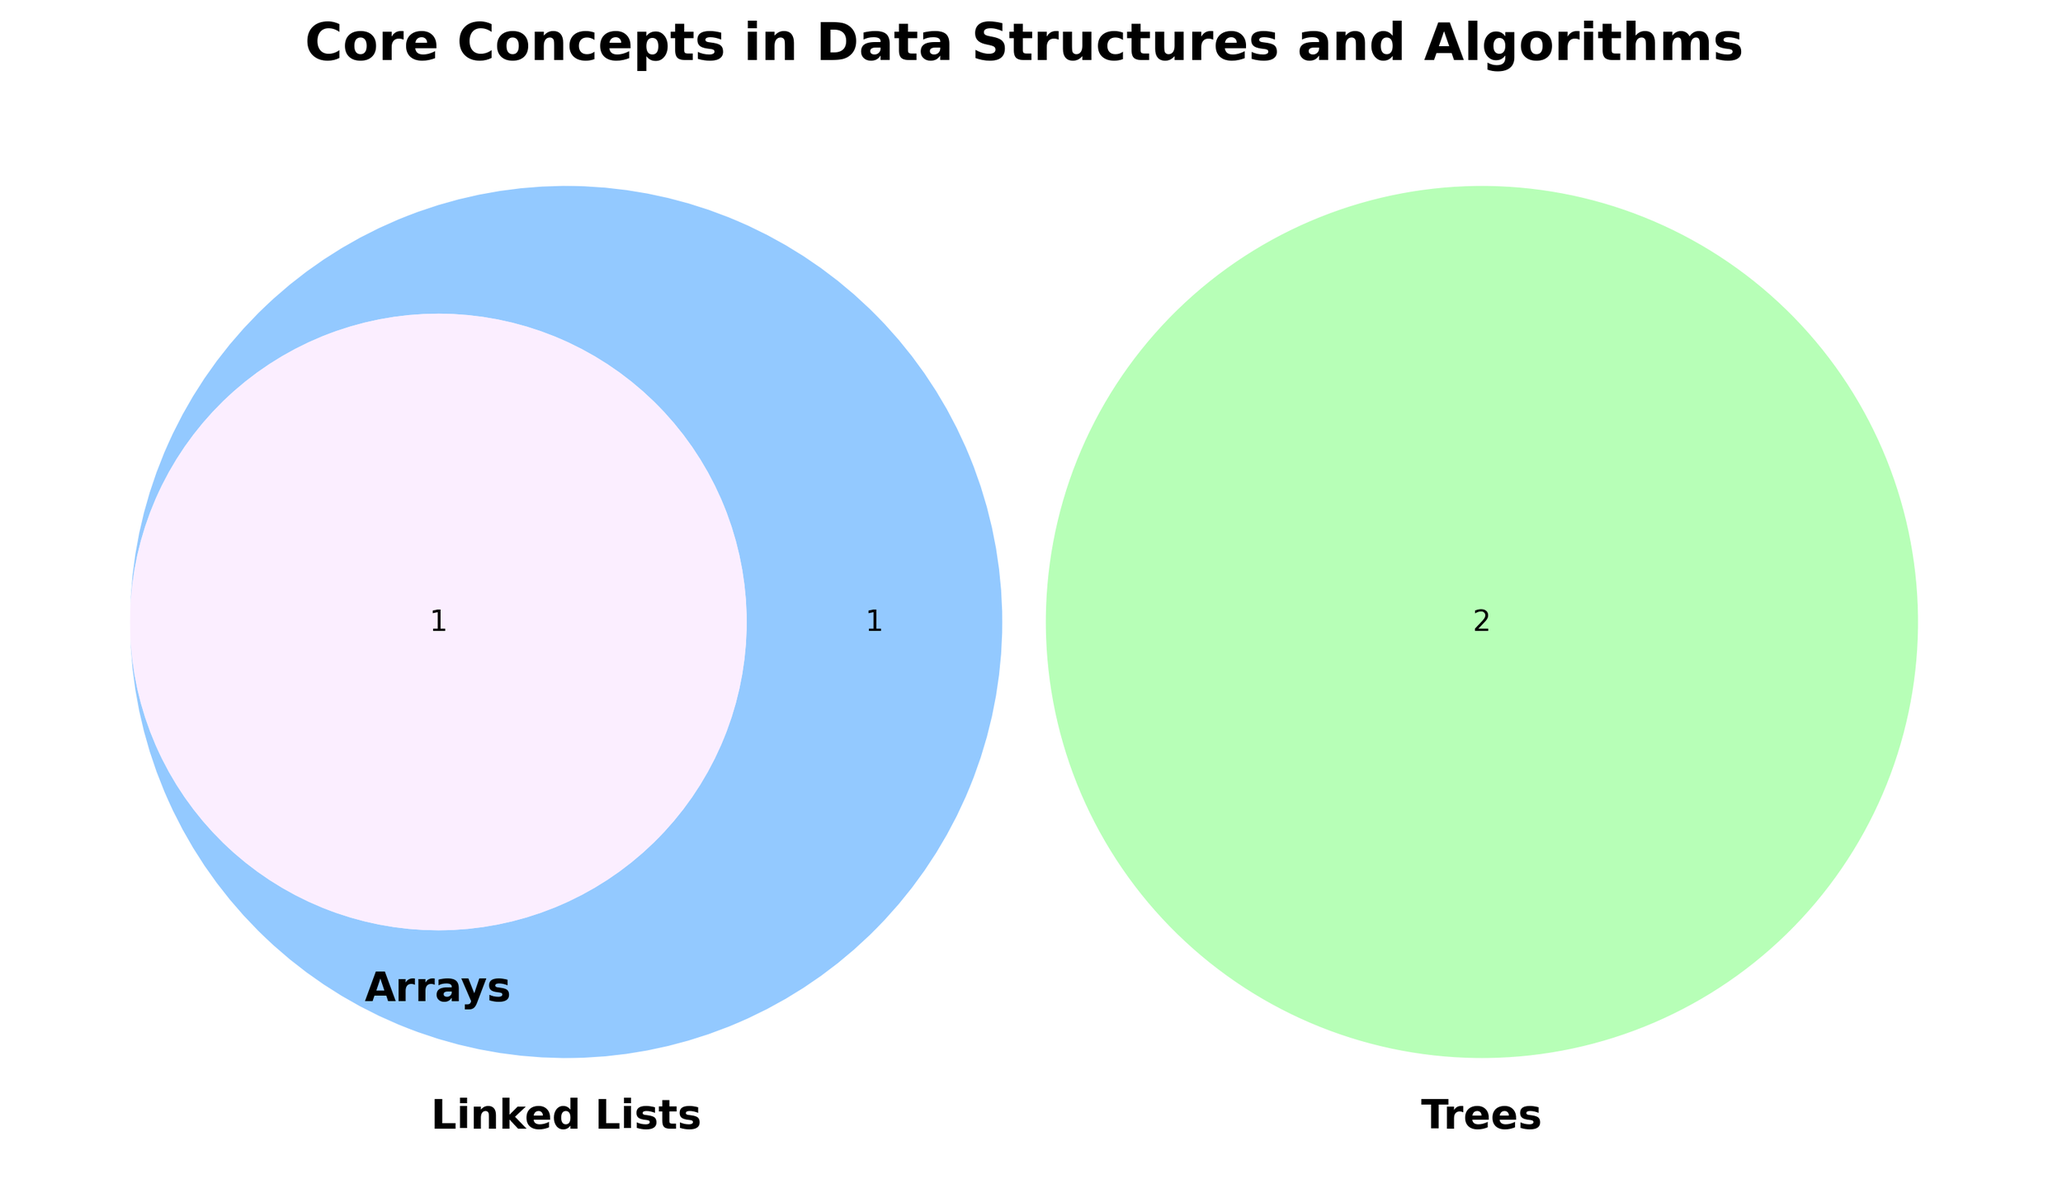What are the three categories represented in the Venn diagram? The figure shows three circles each representing a unique category. The labels on these circles represent the categories.
Answer: Arrays, Linked Lists, Trees Which items are unique to the Trees category? The items exclusive to one circle are unique to that category. The circle for Trees only contains "Hierarchical structure" and "Recursive algorithms".
Answer: Hierarchical structure, Recursive algorithms What common concept is shared between Linked Lists and Arrays? Look for the section where the circles of Linked Lists and Arrays overlap. The item in this section is the shared concept.
Answer: Linear data structure How many items are common to all three categories? The center of the Venn diagram, where all three circles overlap, represents items common to all categories. Count these items.
Answer: 0 Which category shares an item with the most other categories? Identify the circle that overlaps with both of the other circles in the most sections. Count the overlapping items.
Answer: Linked Lists How many items does the Arrays category share with other categories? Look at the sections where the Arrays circle overlaps with Linked Lists and Trees. Add the counts of these items.
Answer: 1 Which item is shared between Linked Lists and Trees but not Arrays? Look at the section between Linked Lists and Trees circles, excluding the part where Arrays also overlaps. Identify the item here.
Answer: Dynamic memory allocation Are there more unique items in Linked Lists or Trees? Count unique items inside each circle by excluding overlaps. Compare the counts for Linked Lists and Trees.
Answer: Trees Which category has the largest number of unique items? Count the unique items in each circle (excluding overlaps) and identify the category with the most unique items.
Answer: Trees 